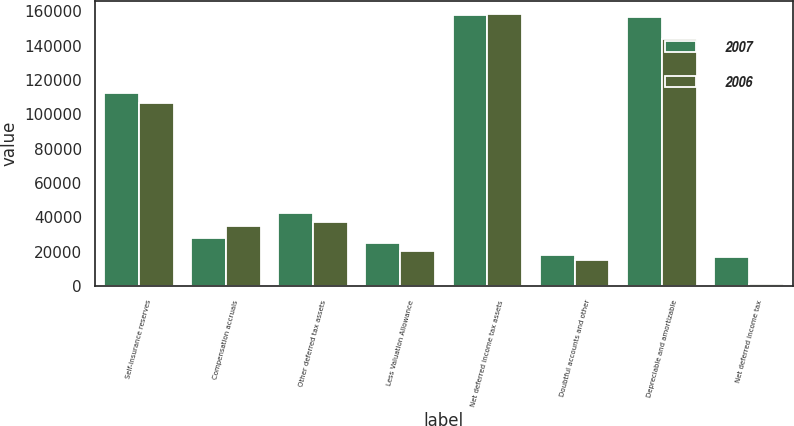<chart> <loc_0><loc_0><loc_500><loc_500><stacked_bar_chart><ecel><fcel>Self-insurance reserves<fcel>Compensation accruals<fcel>Other deferred tax assets<fcel>Less Valuation Allowance<fcel>Net deferred income tax assets<fcel>Doubtful accounts and other<fcel>Depreciable and amortizable<fcel>Net deferred income tax<nl><fcel>2007<fcel>112412<fcel>27848<fcel>42546<fcel>24979<fcel>157827<fcel>18162<fcel>156534<fcel>16869<nl><fcel>2006<fcel>106521<fcel>35016<fcel>37175<fcel>20582<fcel>158130<fcel>15305<fcel>143800<fcel>975<nl></chart> 